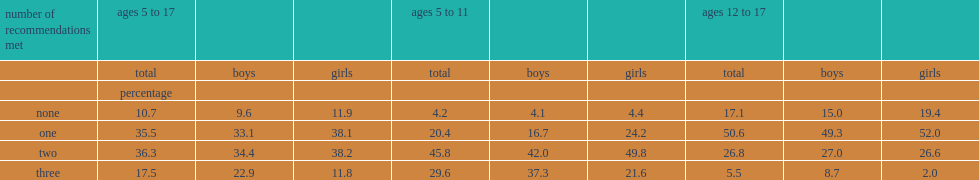What percentage of children aged 5 to 17 meet all the three recommendations? 17.5. What percentage of children who met all three recommendations? 29.6. What percentage of youth who met all three recommendations? 5.5. What is the percentage of boys in 5-11 years old who met three recommendations? 37.3. What is the percentage of boys in 12-17 years old who met three recommendations? 8.7. What is the percentage of girls in 5-11 years old who met three recommendations? 21.6. What is the percentage of girls in 12-17 years old who met three recommendations? 2.0. What is the percentage of 5- to 17- years-old boys who met all three recommendations? 22.9. What is the percentage of 5- to 17- years-old girls who met all three recommendations? 11.8. What is the percentage of children and youth who did not meet any of the recommendations? 10.7. What is the percentage of children and youth who meet at least two recommendations? 53.8. What is the percentage of 5- to 11-year-olds who) met two recommendations? 45.8. What is the percentage of youth who met two recommendations? 26.8. 